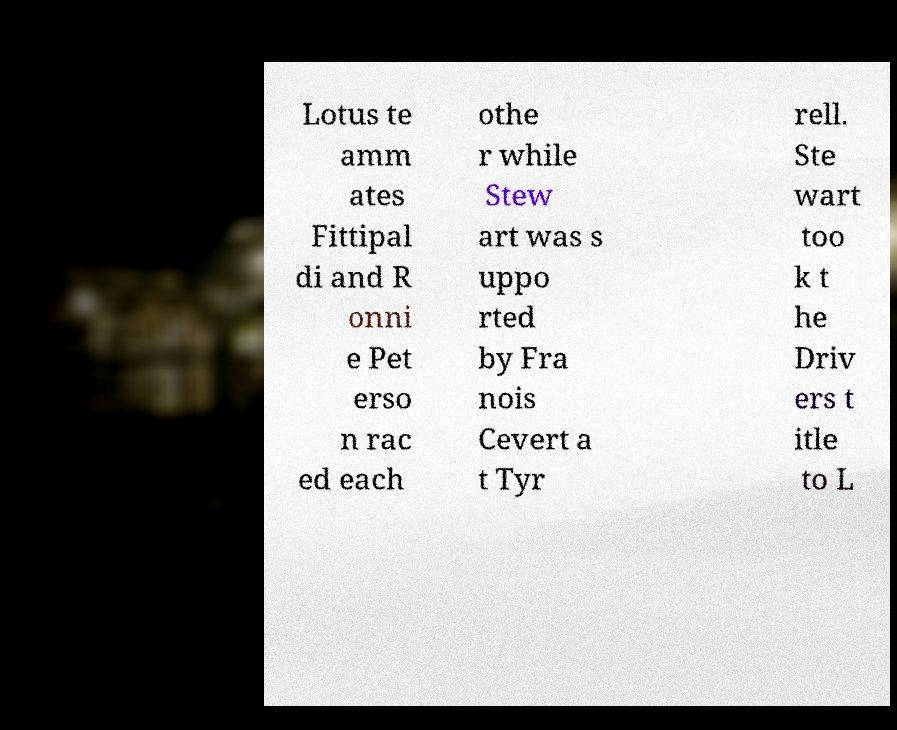Please read and relay the text visible in this image. What does it say? Lotus te amm ates Fittipal di and R onni e Pet erso n rac ed each othe r while Stew art was s uppo rted by Fra nois Cevert a t Tyr rell. Ste wart too k t he Driv ers t itle to L 